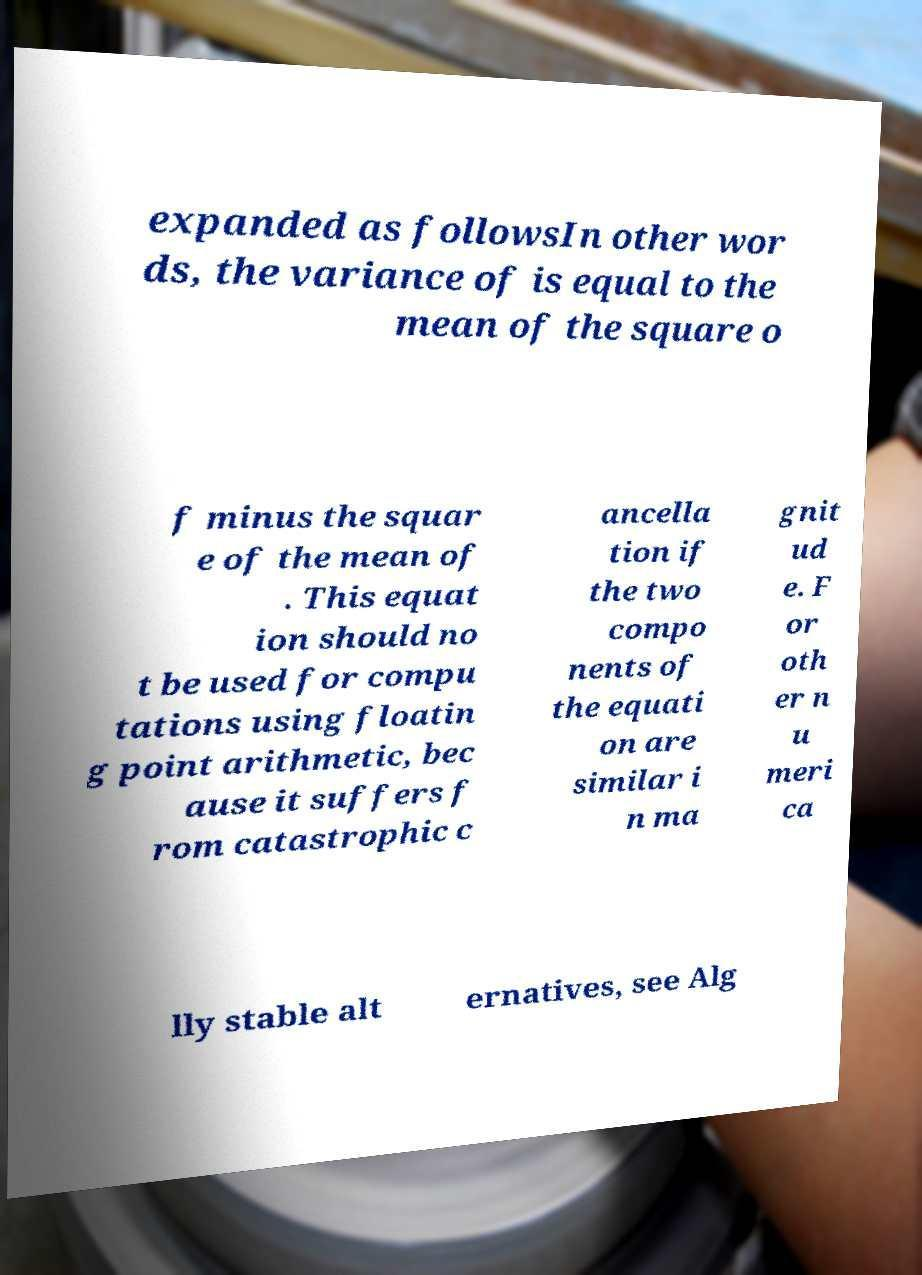Can you accurately transcribe the text from the provided image for me? expanded as followsIn other wor ds, the variance of is equal to the mean of the square o f minus the squar e of the mean of . This equat ion should no t be used for compu tations using floatin g point arithmetic, bec ause it suffers f rom catastrophic c ancella tion if the two compo nents of the equati on are similar i n ma gnit ud e. F or oth er n u meri ca lly stable alt ernatives, see Alg 